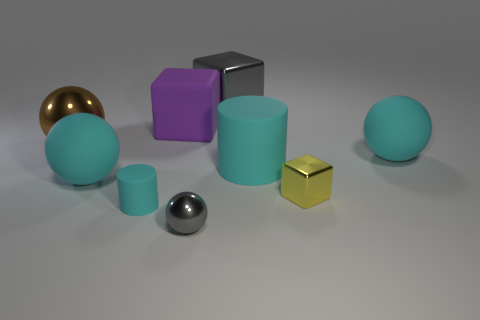Subtract all brown cylinders. How many cyan spheres are left? 2 Subtract all small gray balls. How many balls are left? 3 Subtract 1 blocks. How many blocks are left? 2 Add 1 tiny gray spheres. How many objects exist? 10 Subtract all gray spheres. How many spheres are left? 3 Subtract all gray spheres. Subtract all green blocks. How many spheres are left? 3 Subtract all blocks. How many objects are left? 6 Add 6 cyan spheres. How many cyan spheres exist? 8 Subtract 0 brown blocks. How many objects are left? 9 Subtract all small brown matte balls. Subtract all small cyan things. How many objects are left? 8 